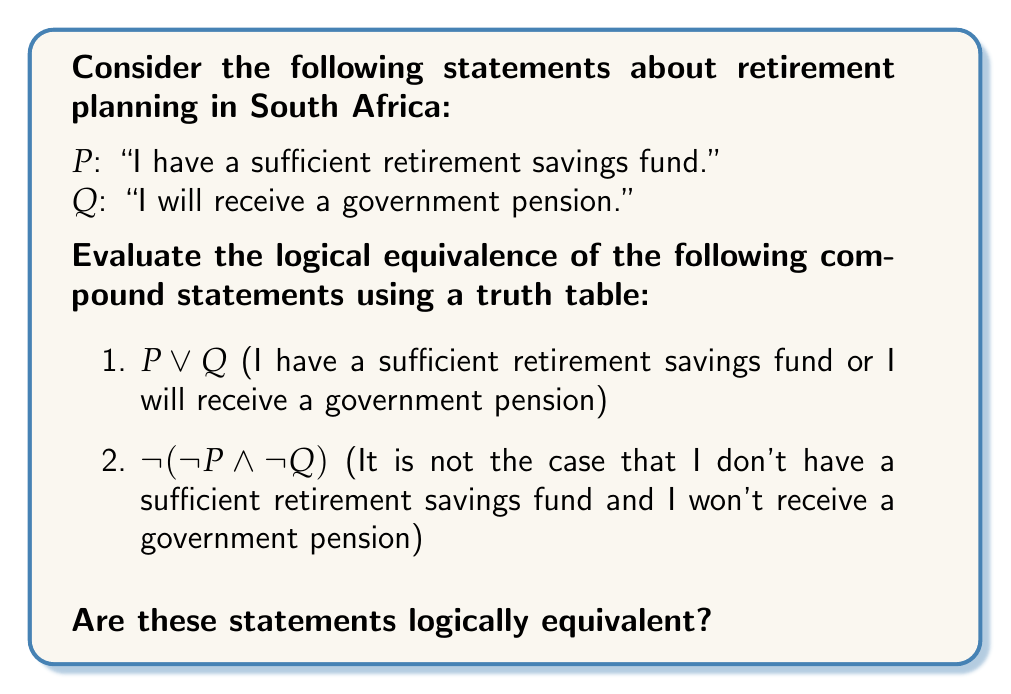Help me with this question. To determine if the statements are logically equivalent, we need to construct a truth table and compare the results for both statements.

Step 1: Identify the atomic propositions
P: "I have a sufficient retirement savings fund."
Q: "I will receive a government pension."

Step 2: Construct the truth table

$$
\begin{array}{|c|c|c|c|c|c|c|}
\hline
P & Q & \neg P & \neg Q & P \lor Q & \neg P \land \neg Q & \neg(\neg P \land \neg Q) \\
\hline
T & T & F & F & T & F & T \\
T & F & F & T & T & F & T \\
F & T & T & F & T & F & T \\
F & F & T & T & F & T & F \\
\hline
\end{array}
$$

Step 3: Evaluate $P \lor Q$
- This is true when either P is true, Q is true, or both are true.

Step 4: Evaluate $\neg(\neg P \land \neg Q)$
- First, we calculate $\neg P \land \neg Q$
- Then, we negate the result

Step 5: Compare the results
- We can see that the results in the $P \lor Q$ column are identical to the results in the $\neg(\neg P \land \neg Q)$ column.

Step 6: Conclusion
Since the truth values for both statements are identical for all possible combinations of P and Q, we can conclude that the statements are logically equivalent.
Answer: Yes, the statements are logically equivalent. 